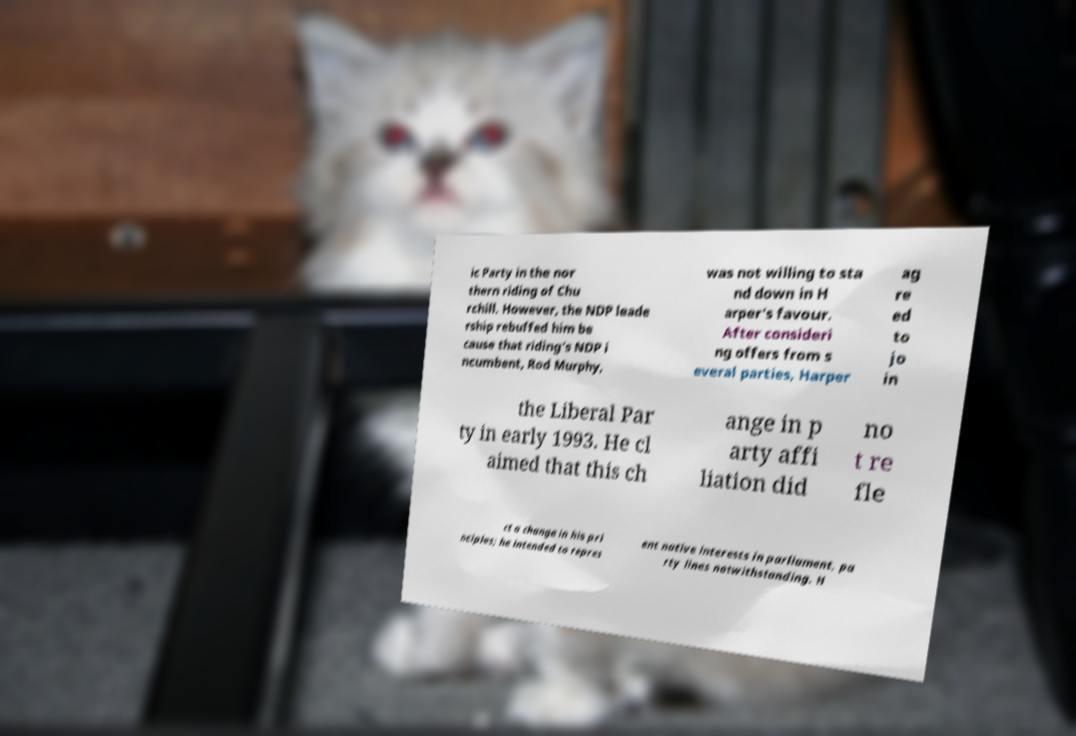Please read and relay the text visible in this image. What does it say? ic Party in the nor thern riding of Chu rchill. However, the NDP leade rship rebuffed him be cause that riding's NDP i ncumbent, Rod Murphy, was not willing to sta nd down in H arper's favour. After consideri ng offers from s everal parties, Harper ag re ed to jo in the Liberal Par ty in early 1993. He cl aimed that this ch ange in p arty affi liation did no t re fle ct a change in his pri nciples; he intended to repres ent native interests in parliament, pa rty lines notwithstanding. H 